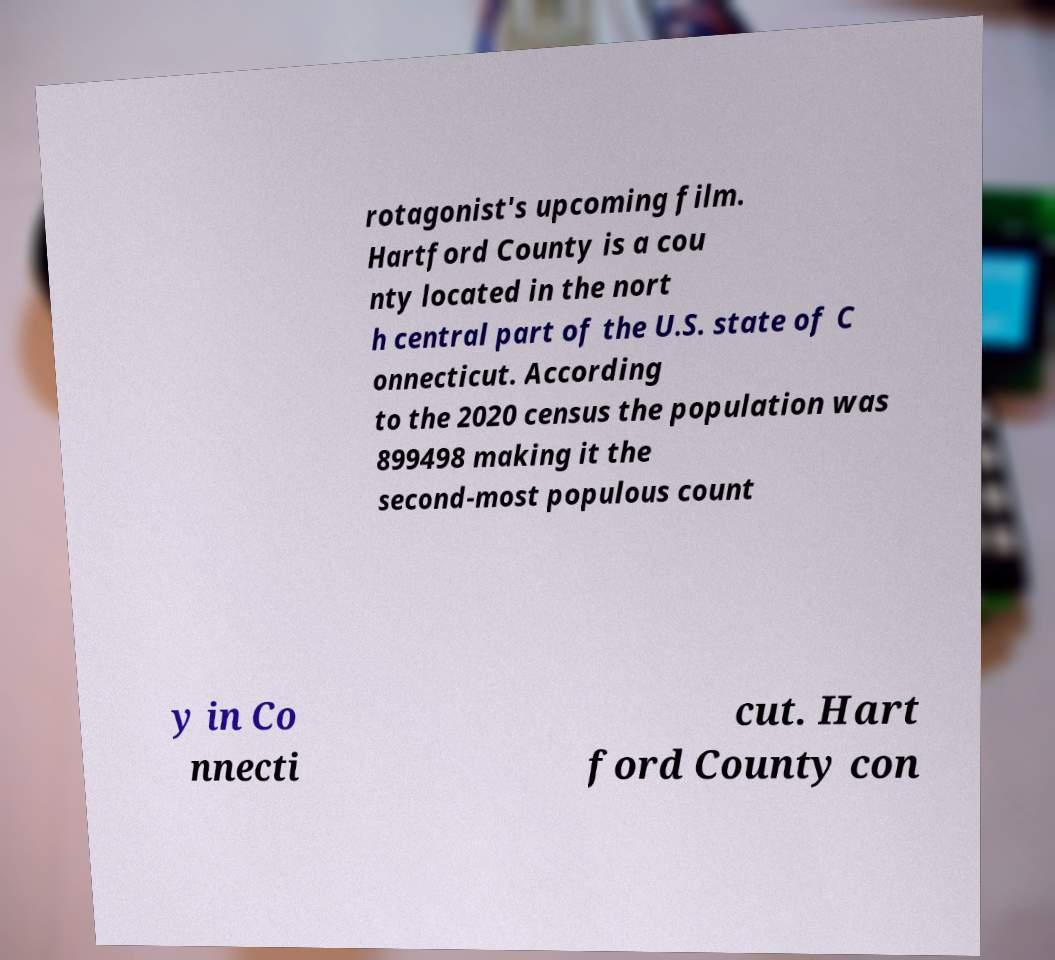Please read and relay the text visible in this image. What does it say? rotagonist's upcoming film. Hartford County is a cou nty located in the nort h central part of the U.S. state of C onnecticut. According to the 2020 census the population was 899498 making it the second-most populous count y in Co nnecti cut. Hart ford County con 